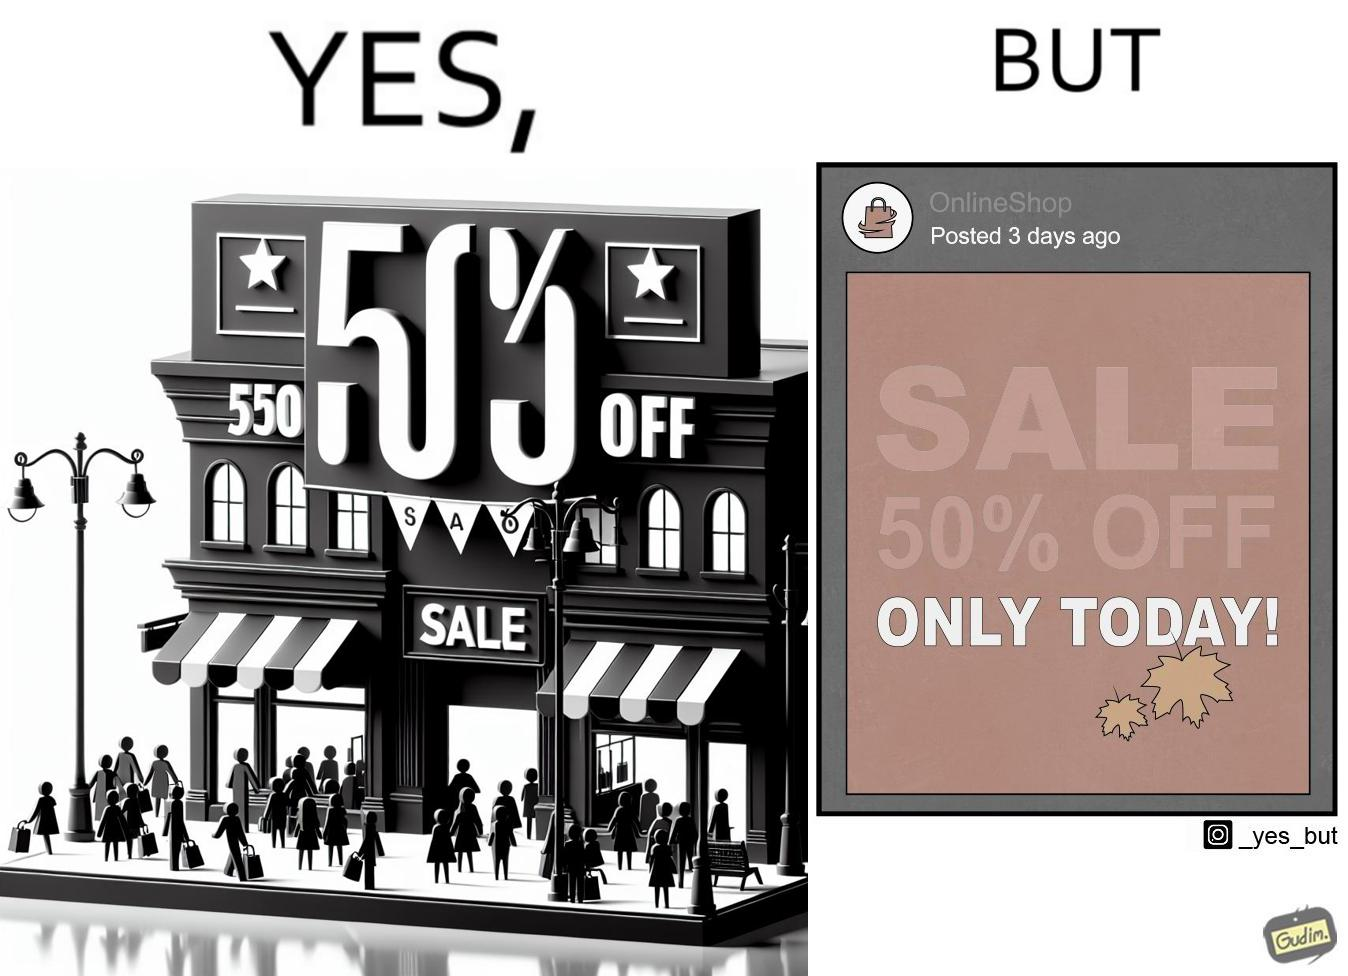What makes this image funny or satirical? The image is ironic, because the poster of sale at a store is posted 3 days ago on a social media account which means the sale which was for only one day has become over 